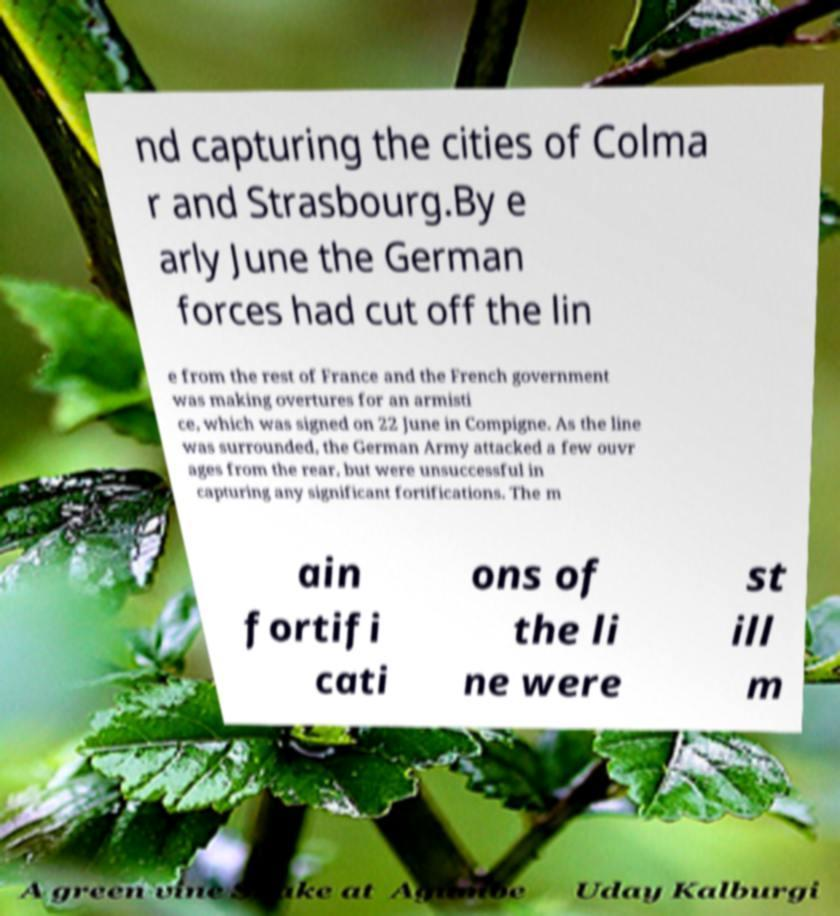I need the written content from this picture converted into text. Can you do that? nd capturing the cities of Colma r and Strasbourg.By e arly June the German forces had cut off the lin e from the rest of France and the French government was making overtures for an armisti ce, which was signed on 22 June in Compigne. As the line was surrounded, the German Army attacked a few ouvr ages from the rear, but were unsuccessful in capturing any significant fortifications. The m ain fortifi cati ons of the li ne were st ill m 